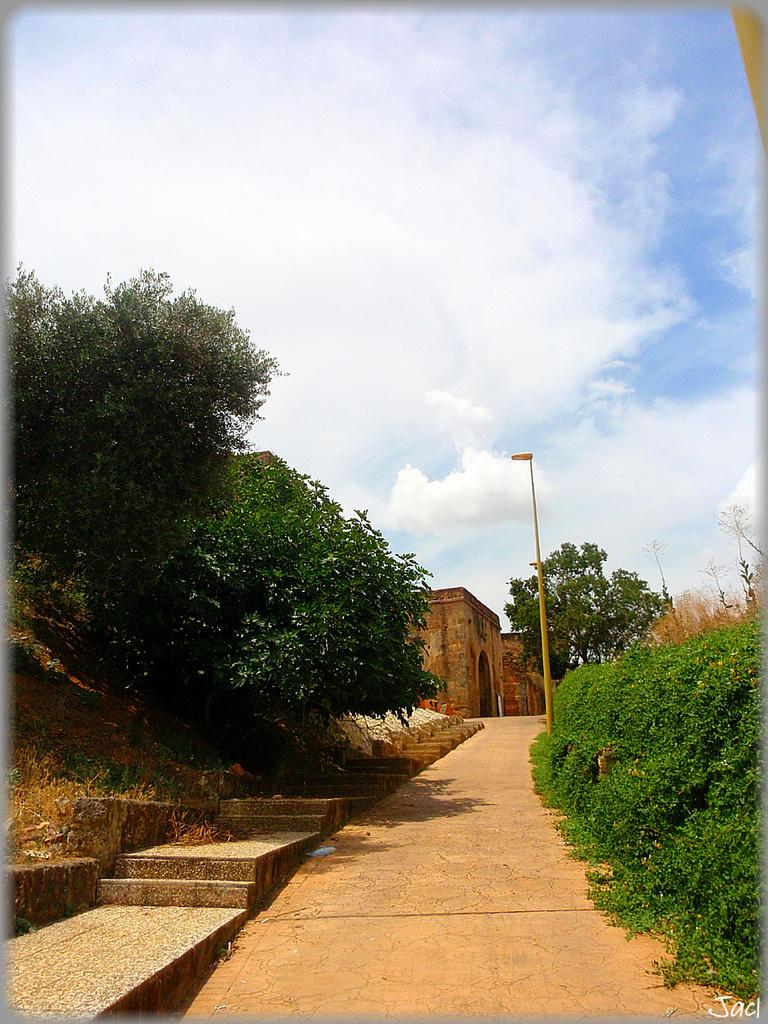What type of pathway can be seen in the image? There is a road in the image. What architectural feature is present in the image? There are steps in the image. What type of vegetation is present on both sides of the image? Trees are present on both sides of the image. What object can be seen in the image that is used for supporting or holding something? There is a pole in the image. What type of structure is visible in the image? There is a stone building in the image. What part of the natural environment is visible in the background of the image? The sky is visible in the background of the image. What can be seen in the sky in the image? Clouds are present in the sky. Can you tell me how many berries are growing on the trees in the image? There is no mention of berries in the image, so it is not possible to determine how many berries might be growing on the trees. Who is the visitor in the image? There is no mention of a visitor in the image. 